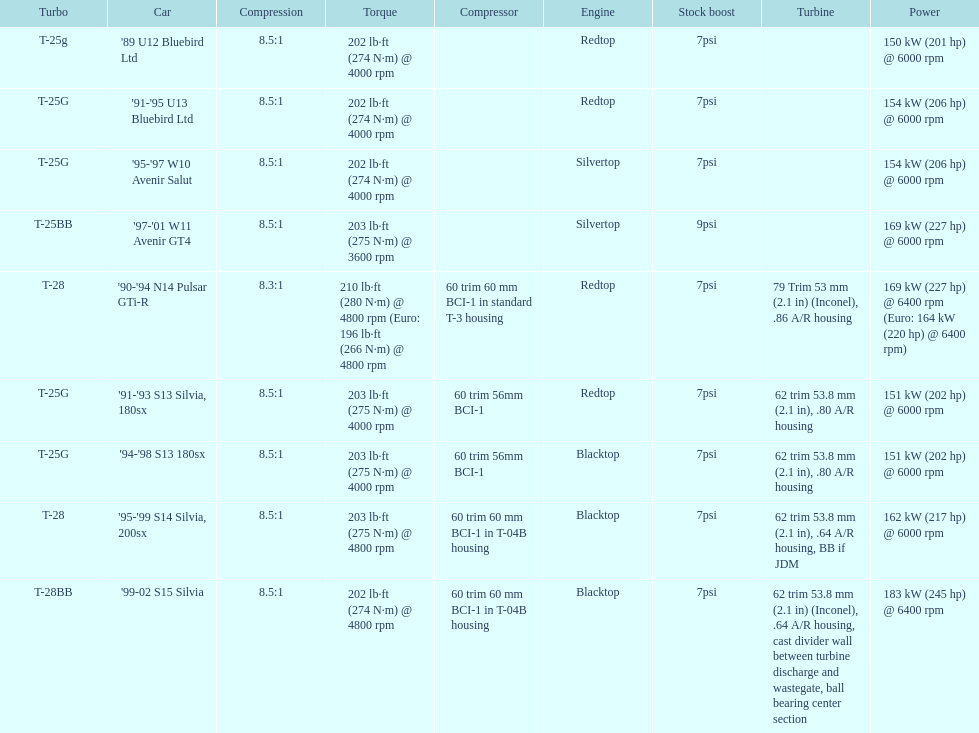Which engines are the same as the first entry ('89 u12 bluebird ltd)? '91-'95 U13 Bluebird Ltd, '90-'94 N14 Pulsar GTi-R, '91-'93 S13 Silvia, 180sx. 